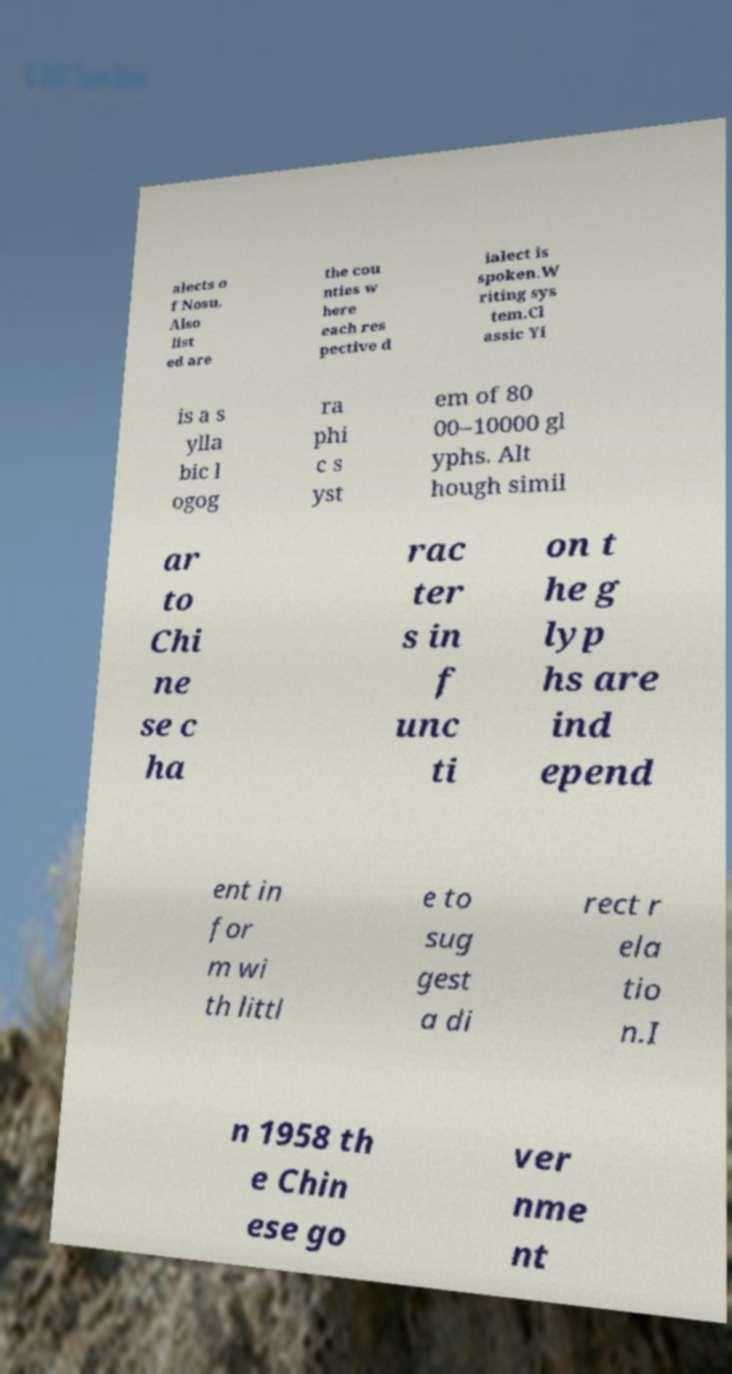There's text embedded in this image that I need extracted. Can you transcribe it verbatim? alects o f Nosu. Also list ed are the cou nties w here each res pective d ialect is spoken.W riting sys tem.Cl assic Yi is a s ylla bic l ogog ra phi c s yst em of 80 00–10000 gl yphs. Alt hough simil ar to Chi ne se c ha rac ter s in f unc ti on t he g lyp hs are ind epend ent in for m wi th littl e to sug gest a di rect r ela tio n.I n 1958 th e Chin ese go ver nme nt 